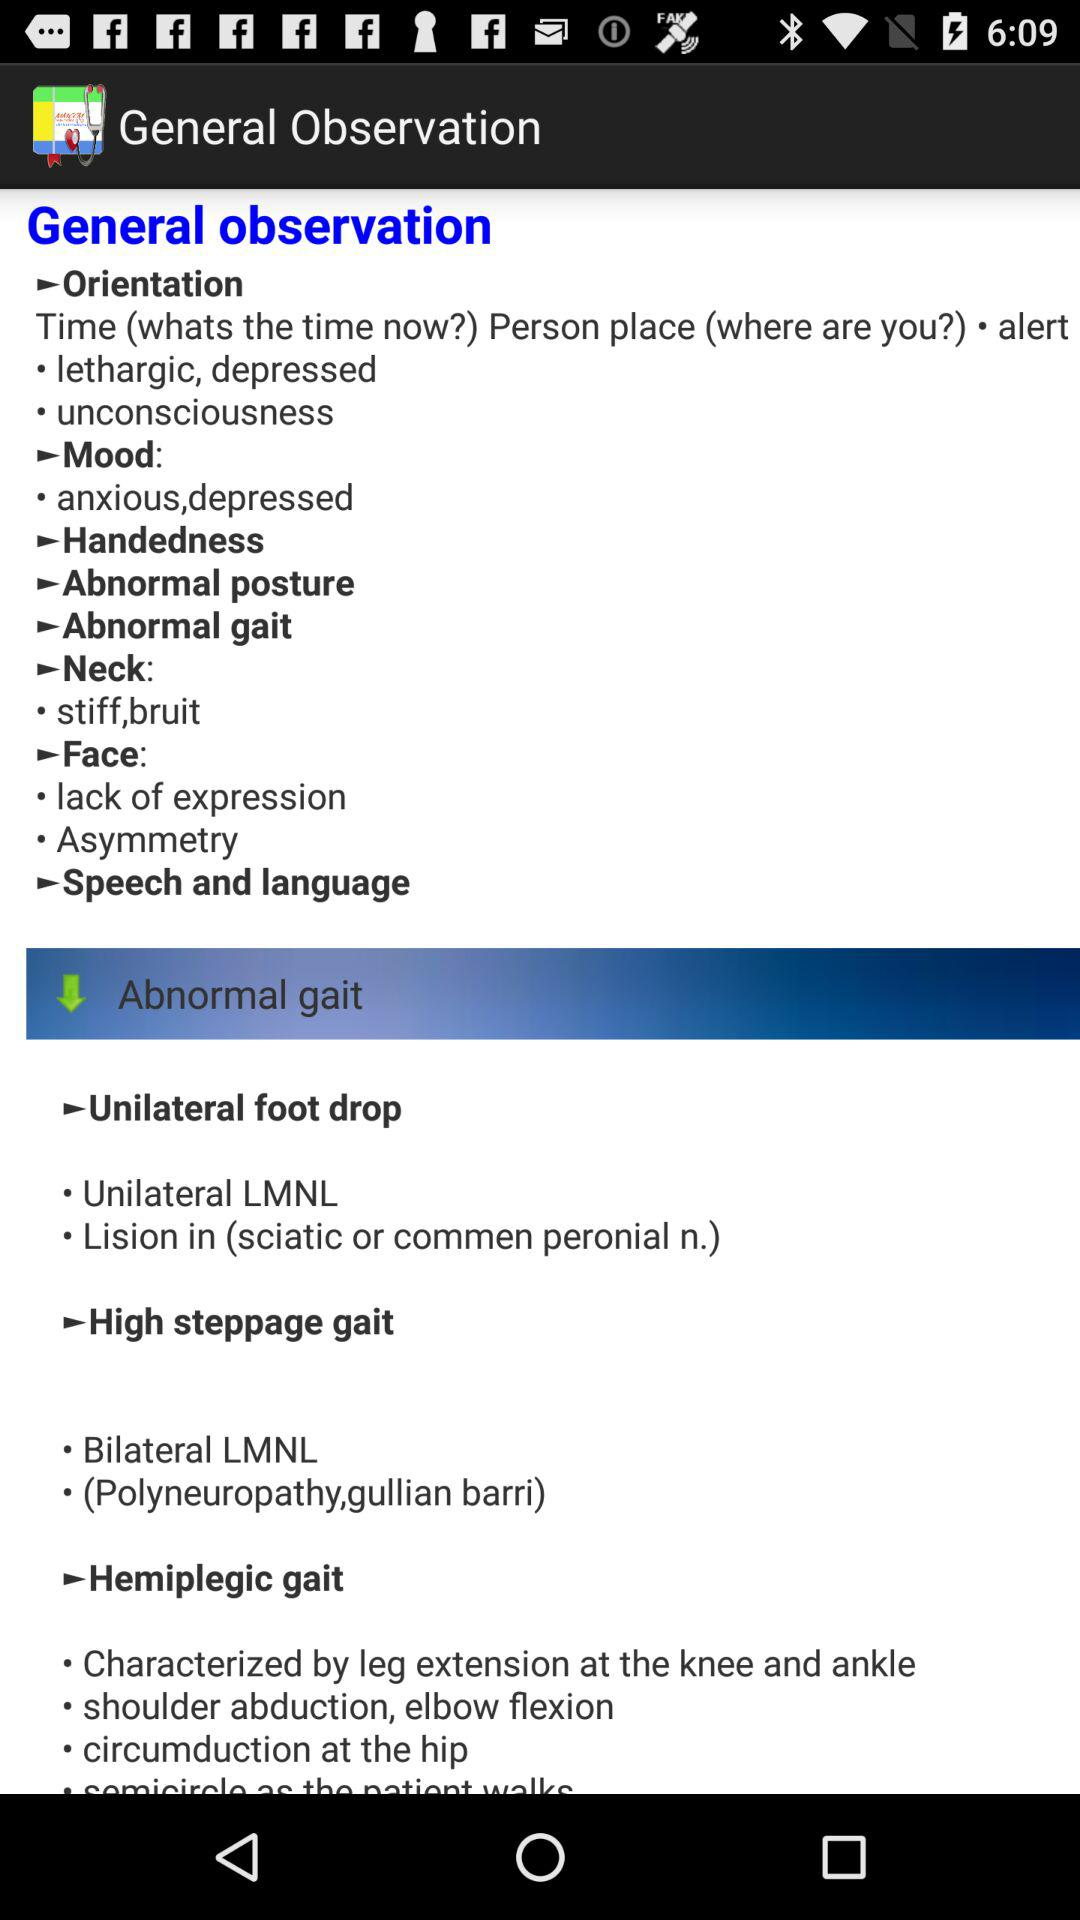What is the mood? The mood is anxious and depressed. 